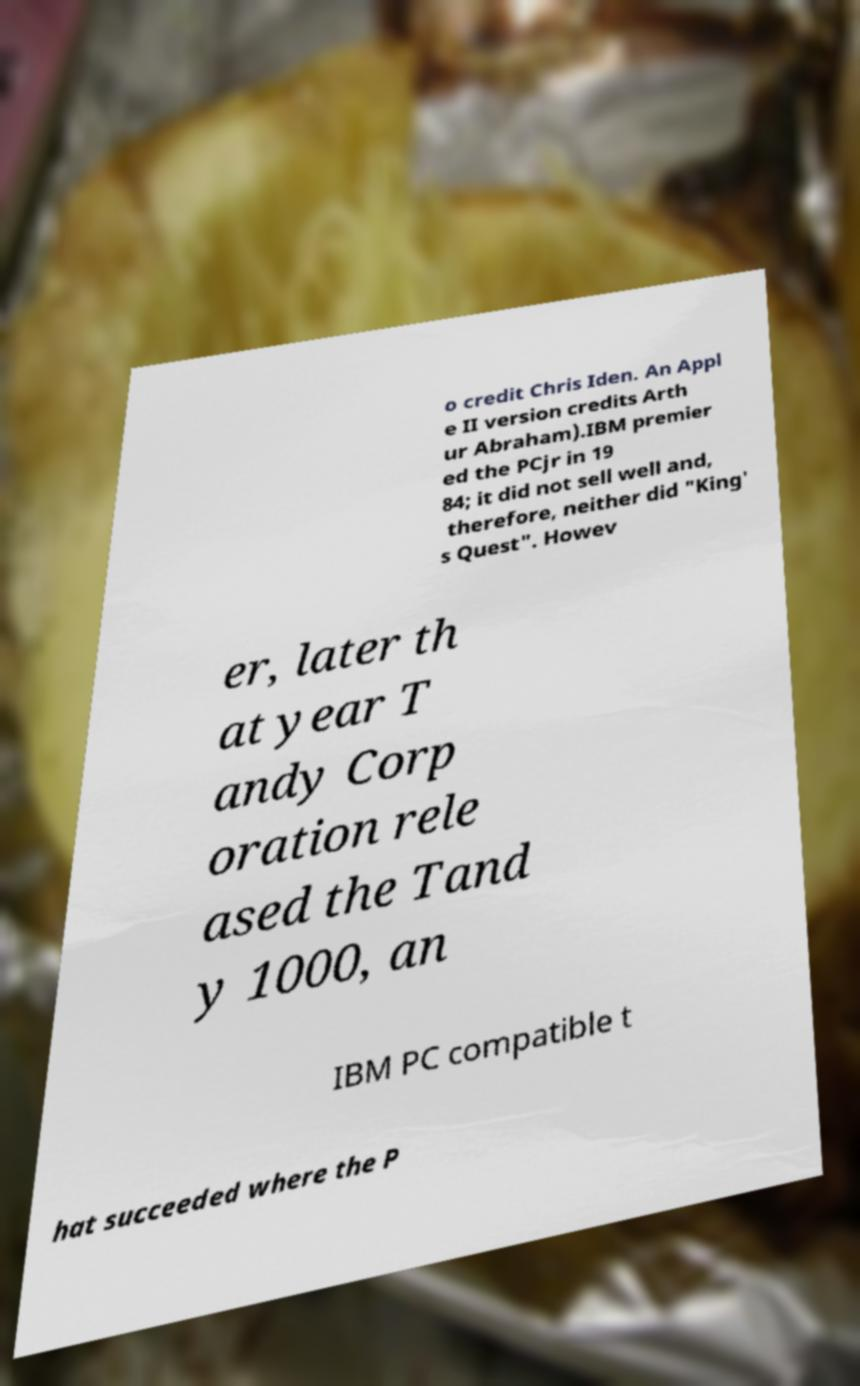Could you extract and type out the text from this image? o credit Chris Iden. An Appl e II version credits Arth ur Abraham).IBM premier ed the PCjr in 19 84; it did not sell well and, therefore, neither did "King' s Quest". Howev er, later th at year T andy Corp oration rele ased the Tand y 1000, an IBM PC compatible t hat succeeded where the P 